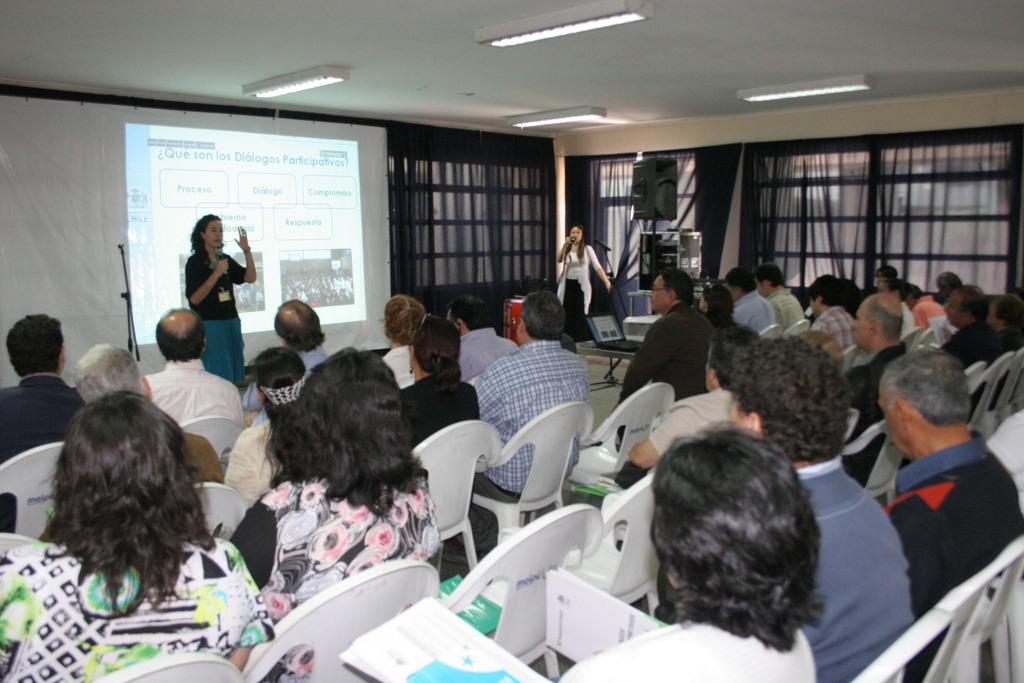In one or two sentences, can you explain what this image depicts? In the center of the image we can see a few people are sitting on the chairs. And we can see a few people are holding some objects. In the background there is a wall, screen, curtains, two persons are standing and holding some objects and a few other objects. 